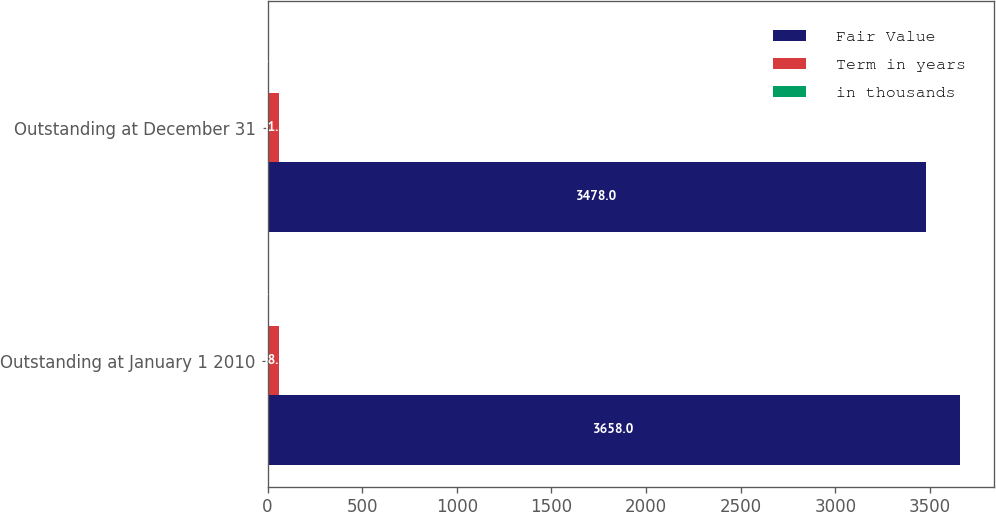<chart> <loc_0><loc_0><loc_500><loc_500><stacked_bar_chart><ecel><fcel>Outstanding at January 1 2010<fcel>Outstanding at December 31<nl><fcel>Fair Value<fcel>3658<fcel>3478<nl><fcel>Term in years<fcel>58<fcel>61<nl><fcel>in thousands<fcel>1.6<fcel>1.6<nl></chart> 